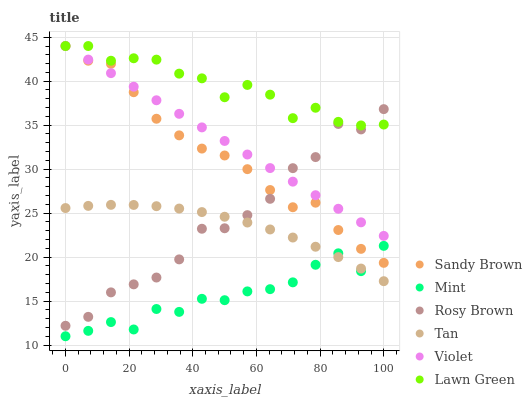Does Mint have the minimum area under the curve?
Answer yes or no. Yes. Does Lawn Green have the maximum area under the curve?
Answer yes or no. Yes. Does Sandy Brown have the minimum area under the curve?
Answer yes or no. No. Does Sandy Brown have the maximum area under the curve?
Answer yes or no. No. Is Violet the smoothest?
Answer yes or no. Yes. Is Rosy Brown the roughest?
Answer yes or no. Yes. Is Sandy Brown the smoothest?
Answer yes or no. No. Is Sandy Brown the roughest?
Answer yes or no. No. Does Mint have the lowest value?
Answer yes or no. Yes. Does Sandy Brown have the lowest value?
Answer yes or no. No. Does Violet have the highest value?
Answer yes or no. Yes. Does Rosy Brown have the highest value?
Answer yes or no. No. Is Mint less than Rosy Brown?
Answer yes or no. Yes. Is Lawn Green greater than Mint?
Answer yes or no. Yes. Does Tan intersect Mint?
Answer yes or no. Yes. Is Tan less than Mint?
Answer yes or no. No. Is Tan greater than Mint?
Answer yes or no. No. Does Mint intersect Rosy Brown?
Answer yes or no. No. 